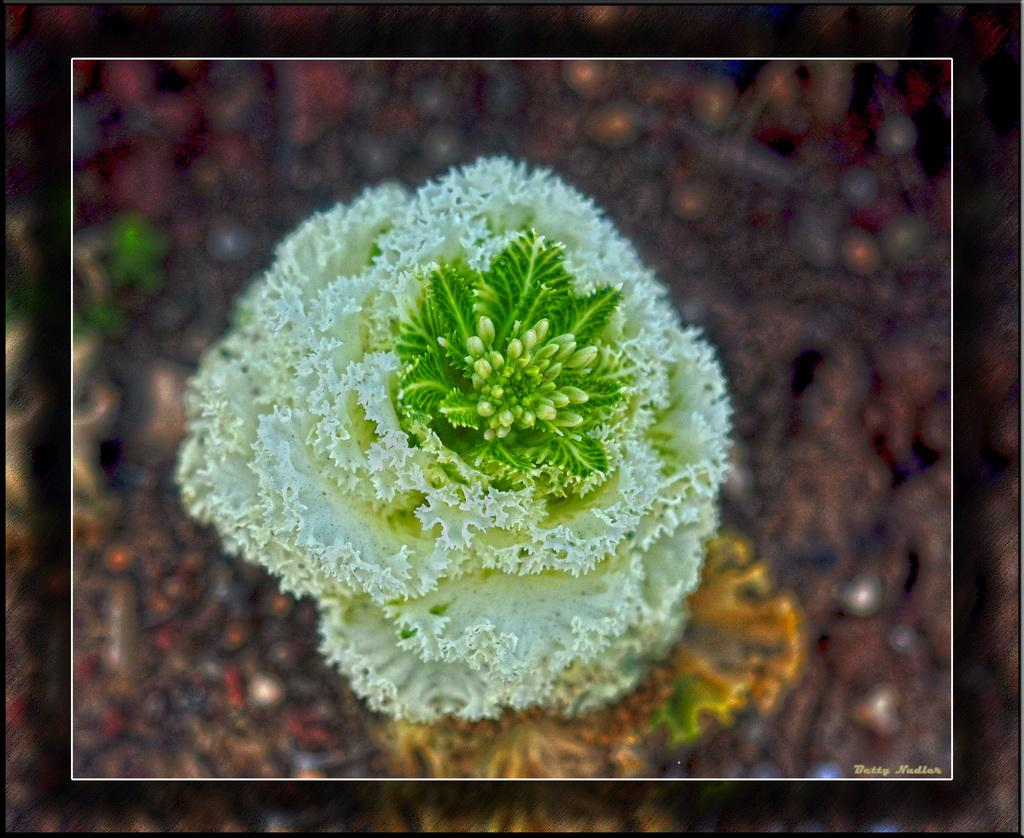What type of plant is visible in the image? There is a flowering plant in the image. What type of animal is sitting on the sofa in the image? There is no animal or sofa present in the image; it only features a flowering plant. Can you tell me how many ears are visible on the plant in the image? Plants do not have ears, so there are no ears visible on the plant in the image. 